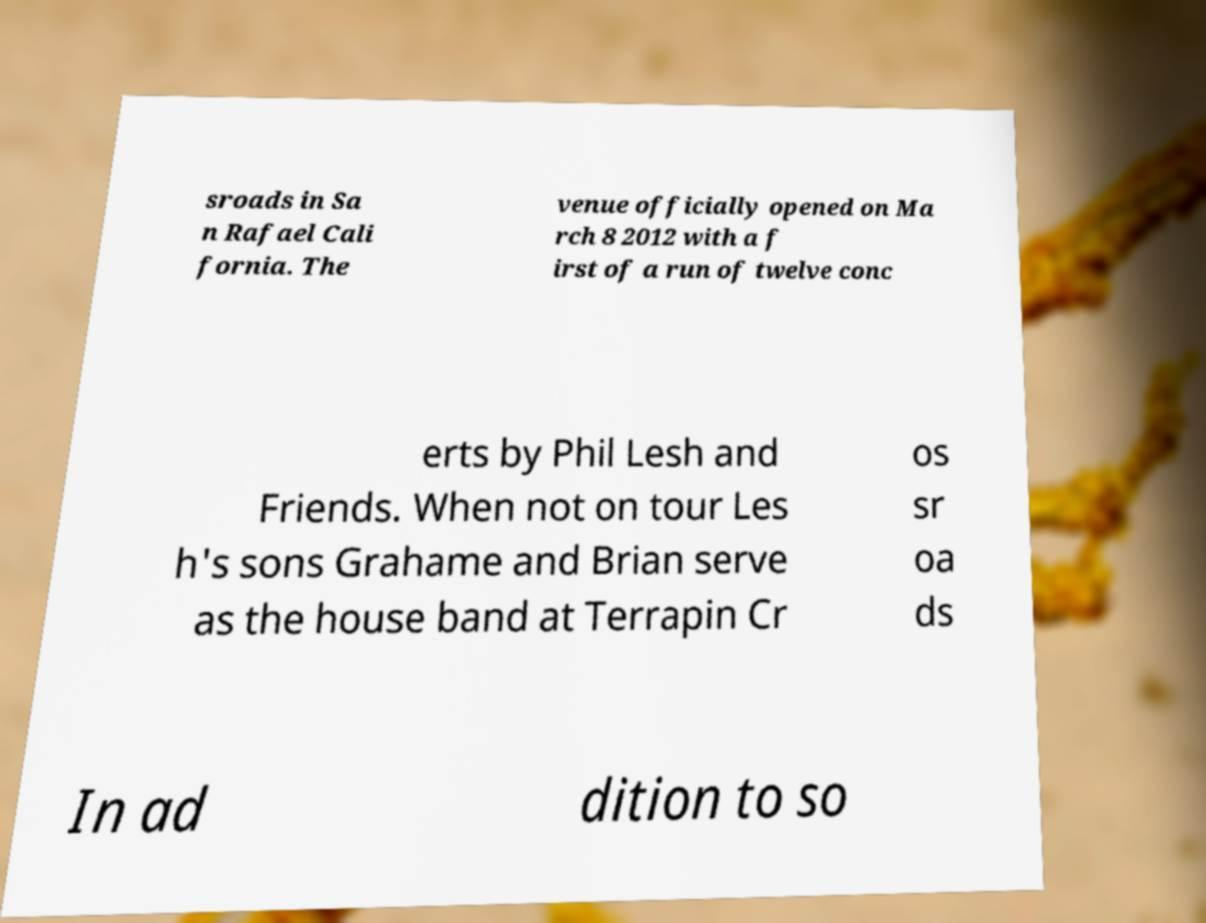There's text embedded in this image that I need extracted. Can you transcribe it verbatim? sroads in Sa n Rafael Cali fornia. The venue officially opened on Ma rch 8 2012 with a f irst of a run of twelve conc erts by Phil Lesh and Friends. When not on tour Les h's sons Grahame and Brian serve as the house band at Terrapin Cr os sr oa ds In ad dition to so 